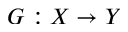Convert formula to latex. <formula><loc_0><loc_0><loc_500><loc_500>G \colon X \rightarrow Y</formula> 